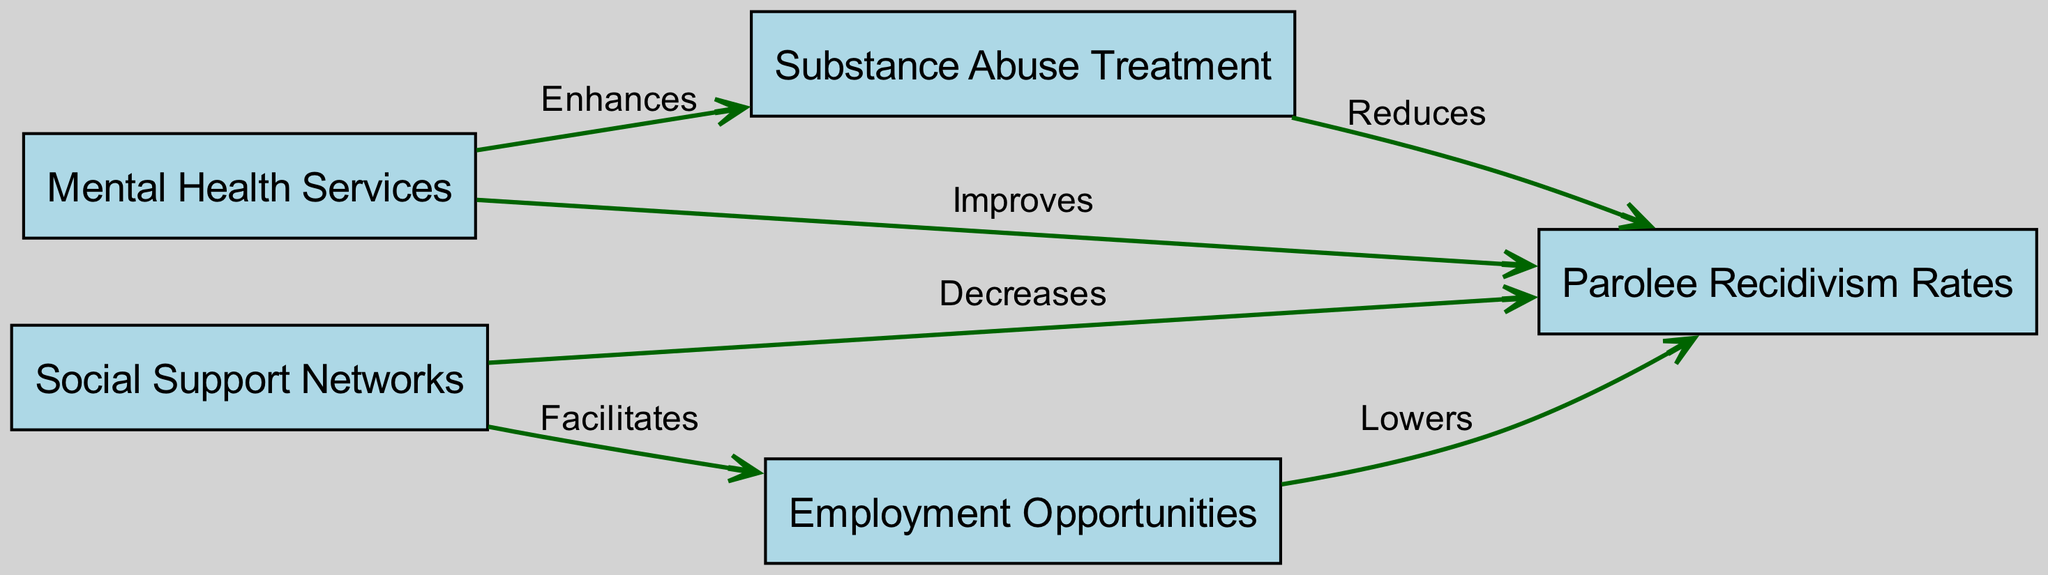What is the label of the node connected to "MentalHealthServices"? The diagram shows that "MentalHealthServices" is connected to "Parolee Recidivism Rates" through an edge labeled "Improves".
Answer: Parolee Recidivism Rates How many nodes are present in the diagram? By counting the unique elements in the nodes list, there are five distinct nodes: Mental Health Services, Substance Abuse Treatment, Social Support Networks, Parolee Recidivism Rates, and Employment Opportunities.
Answer: Five Which node has a direct connection labeled "Reduces"? The edge from "Substance Abuse Treatment" to "Parolee Recidivism Rates" is labeled "Reduces", indicating that "Substance Abuse Treatment" has this direct connection.
Answer: Substance Abuse Treatment What relationship does "Social Support" have with "Employment Opportunities"? The edge from "Social Support" to "Employment Opportunities" is labeled "Facilitates", indicating a supportive relationship between these two nodes.
Answer: Facilitates Which node impacts "Parolee Recidivism Rates" the most based on the edges? The edges indicate various effects on "Parolee Recidivism Rates", but the node that explicitly mentions a reduction is "Substance Abuse Treatment" with the label "Reduces", implying it impacts recidivism rates significantly.
Answer: Reduces How does "Mental Health Services" affect "Substance Abuse Treatment"? The diagram shows a directed edge from "Mental Health Services" to "Substance Abuse Treatment", labeled "Enhances", indicating that the services for mental health improve substance abuse treatment outcomes.
Answer: Enhances Which two nodes are connected through an edge that indicates a decrease in recidivism? "Social Support" is connected to "Parolee Recidivism Rates" with an edge labeled "Decreases", showing this relationship.
Answer: Social Support and Parolee Recidivism Rates What effect do "Employment Opportunities" have on "Parolee Recidivism Rates"? The edge from "Employment Opportunities" to "Parolee Recidivism Rates" is labeled "Lowers", indicating that increased employment opportunities lead to a reduction in recidivism rates.
Answer: Lowers Which node serves as a source that connects two other nodes, namely "Social Support" and "Employment Opportunities"? The "Social Support" node has an edge leading to "Employment Opportunities", facilitating the connection between the two.
Answer: Social Support 